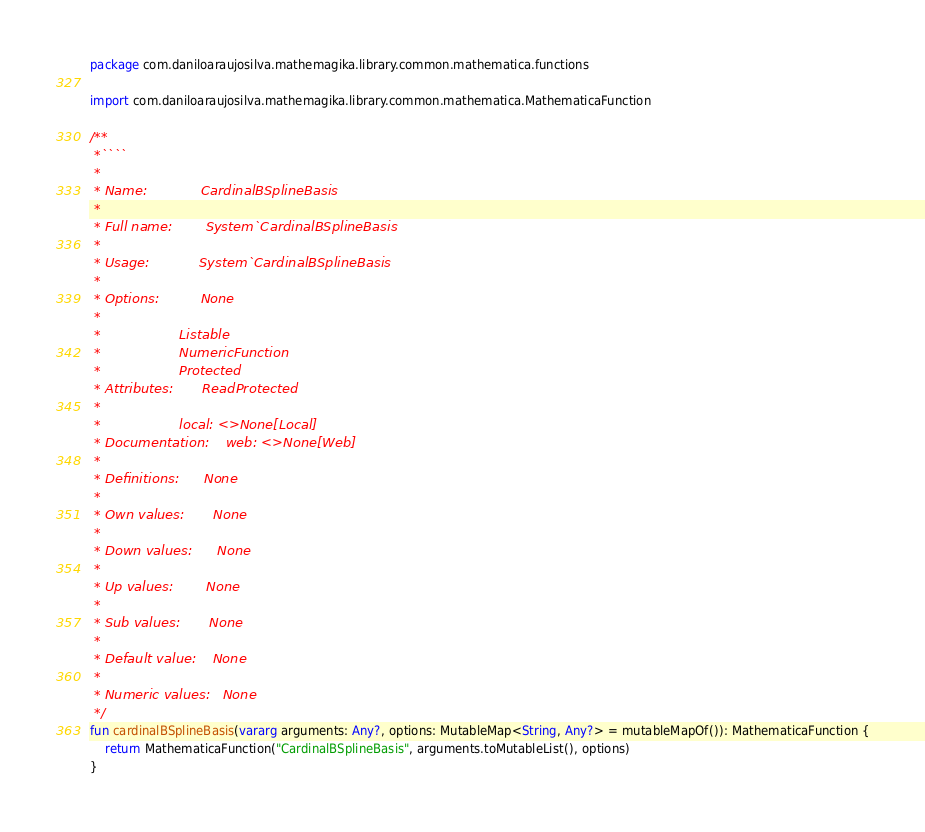<code> <loc_0><loc_0><loc_500><loc_500><_Kotlin_>package com.daniloaraujosilva.mathemagika.library.common.mathematica.functions

import com.daniloaraujosilva.mathemagika.library.common.mathematica.MathematicaFunction

/**
 *````
 *
 * Name:             CardinalBSplineBasis
 *
 * Full name:        System`CardinalBSplineBasis
 *
 * Usage:            System`CardinalBSplineBasis
 *
 * Options:          None
 *
 *                   Listable
 *                   NumericFunction
 *                   Protected
 * Attributes:       ReadProtected
 *
 *                   local: <>None[Local]
 * Documentation:    web: <>None[Web]
 *
 * Definitions:      None
 *
 * Own values:       None
 *
 * Down values:      None
 *
 * Up values:        None
 *
 * Sub values:       None
 *
 * Default value:    None
 *
 * Numeric values:   None
 */
fun cardinalBSplineBasis(vararg arguments: Any?, options: MutableMap<String, Any?> = mutableMapOf()): MathematicaFunction {
	return MathematicaFunction("CardinalBSplineBasis", arguments.toMutableList(), options)
}
</code> 